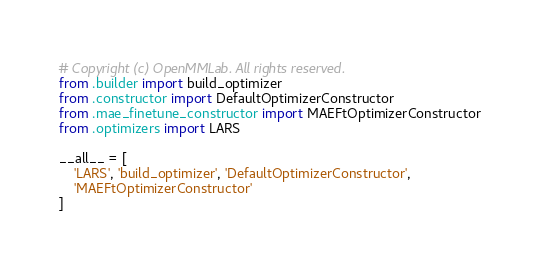Convert code to text. <code><loc_0><loc_0><loc_500><loc_500><_Python_># Copyright (c) OpenMMLab. All rights reserved.
from .builder import build_optimizer
from .constructor import DefaultOptimizerConstructor
from .mae_finetune_constructor import MAEFtOptimizerConstructor
from .optimizers import LARS

__all__ = [
    'LARS', 'build_optimizer', 'DefaultOptimizerConstructor',
    'MAEFtOptimizerConstructor'
]
</code> 